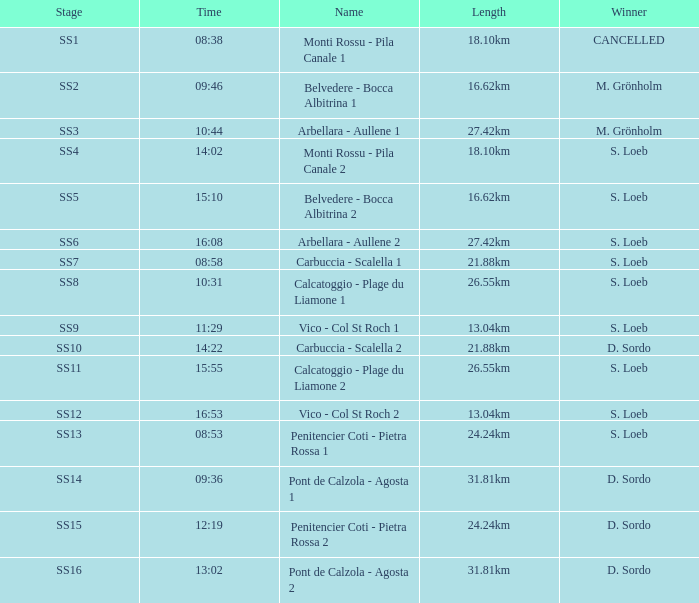62km in length and 15:10 in time? Belvedere - Bocca Albitrina 2. 